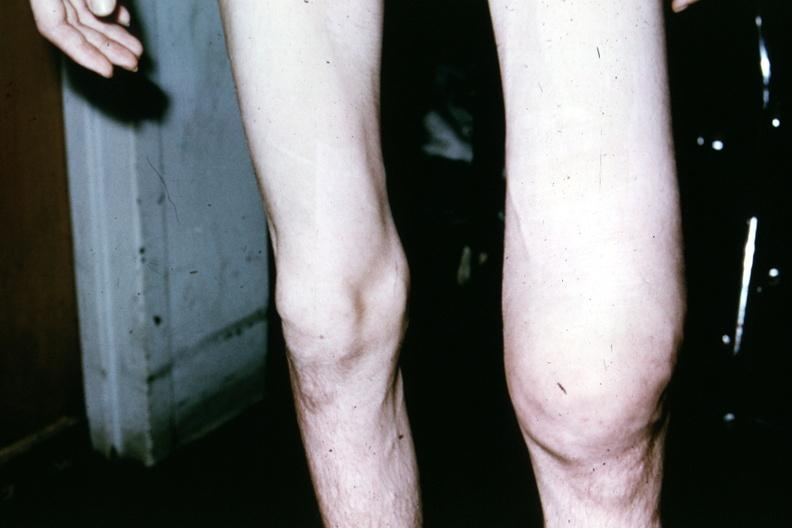s joints present?
Answer the question using a single word or phrase. Yes 